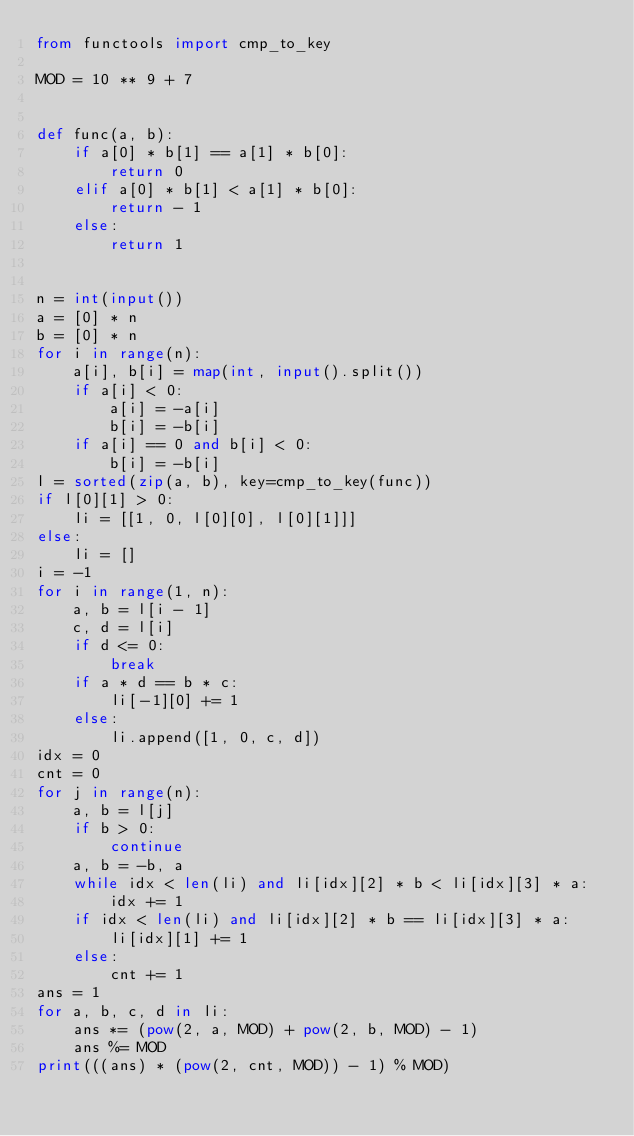Convert code to text. <code><loc_0><loc_0><loc_500><loc_500><_Python_>from functools import cmp_to_key

MOD = 10 ** 9 + 7


def func(a, b):
    if a[0] * b[1] == a[1] * b[0]:
        return 0
    elif a[0] * b[1] < a[1] * b[0]:
        return - 1
    else:
        return 1


n = int(input())
a = [0] * n
b = [0] * n
for i in range(n):
    a[i], b[i] = map(int, input().split())
    if a[i] < 0:
        a[i] = -a[i]
        b[i] = -b[i]
    if a[i] == 0 and b[i] < 0:
        b[i] = -b[i]
l = sorted(zip(a, b), key=cmp_to_key(func))
if l[0][1] > 0:
    li = [[1, 0, l[0][0], l[0][1]]]
else:
    li = []
i = -1
for i in range(1, n):
    a, b = l[i - 1]
    c, d = l[i]
    if d <= 0:
        break
    if a * d == b * c:
        li[-1][0] += 1
    else:
        li.append([1, 0, c, d])
idx = 0
cnt = 0
for j in range(n):
    a, b = l[j]
    if b > 0:
        continue
    a, b = -b, a
    while idx < len(li) and li[idx][2] * b < li[idx][3] * a:
        idx += 1
    if idx < len(li) and li[idx][2] * b == li[idx][3] * a:
        li[idx][1] += 1
    else:
        cnt += 1
ans = 1
for a, b, c, d in li:
    ans *= (pow(2, a, MOD) + pow(2, b, MOD) - 1)
    ans %= MOD
print(((ans) * (pow(2, cnt, MOD)) - 1) % MOD)
</code> 